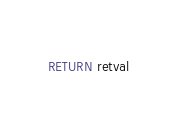Convert code to text. <code><loc_0><loc_0><loc_500><loc_500><_SQL_>RETURN retval
</code> 